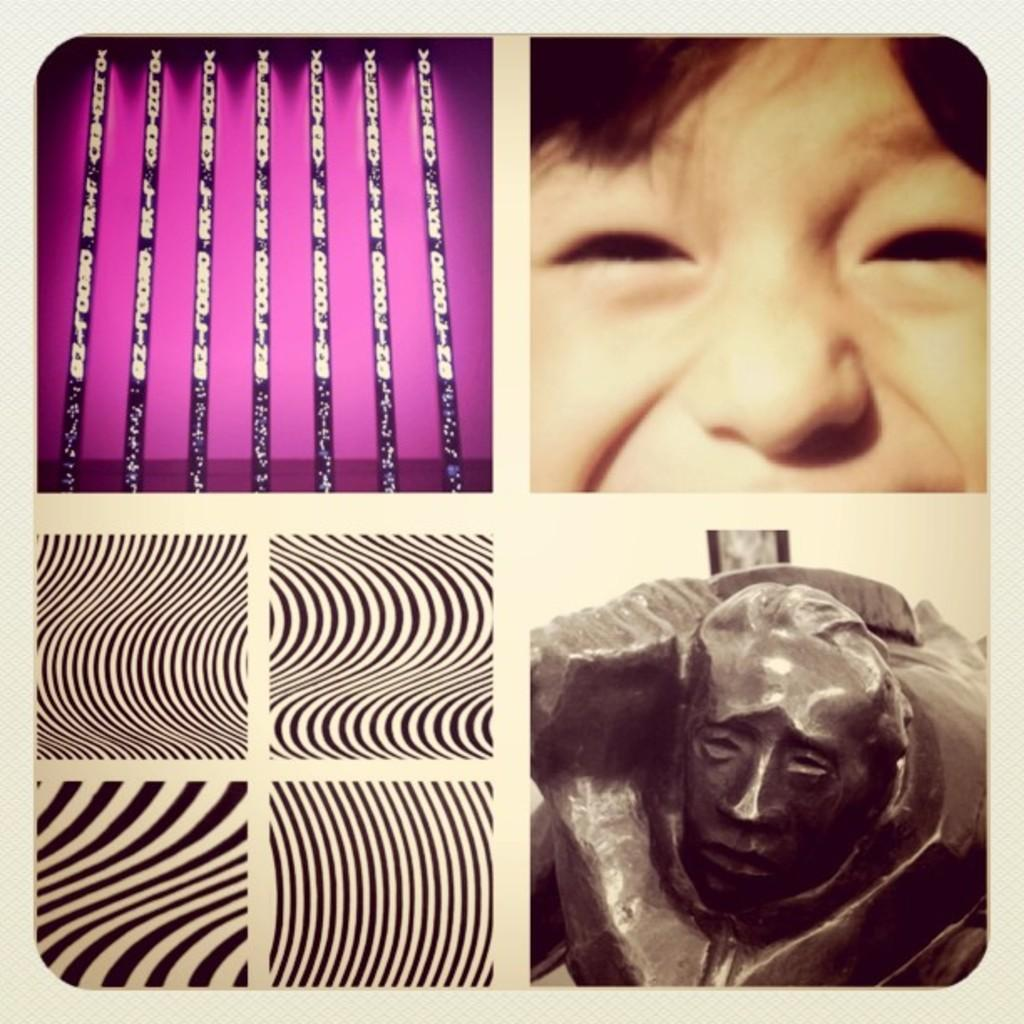What type of artwork is depicted in the image? The image is a collage. What elements can be found in the collage? There are faces of persons, sculptures, various objects, and black and white designs in the collage. How many pizzas are included in the collage? There are no pizzas present in the collage. What type of fruit is depicted in the collage? There is no fruit, such as a pear, depicted in the collage. 